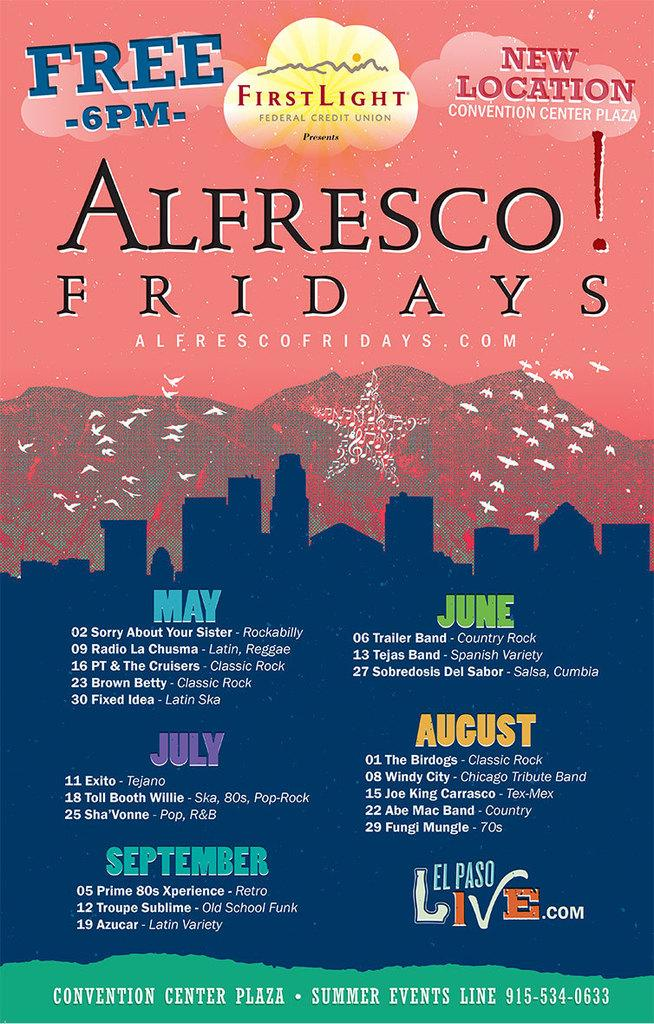<image>
Create a compact narrative representing the image presented. A poster detailing an event called Alfresco! Fridays that is a series of concerts at the Convention Center Plaza. 